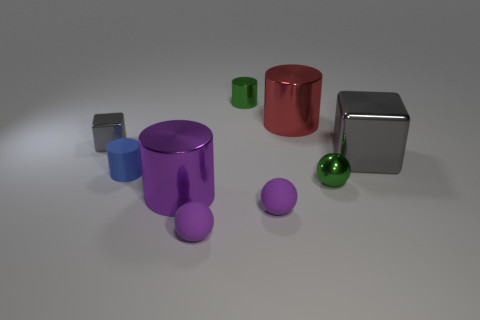What size is the other shiny block that is the same color as the big shiny block?
Your answer should be very brief. Small. What is the material of the other block that is the same color as the tiny cube?
Your response must be concise. Metal. How many red things are the same shape as the big gray object?
Offer a terse response. 0. Is the material of the tiny object behind the tiny gray shiny object the same as the gray cube to the left of the green metallic ball?
Make the answer very short. Yes. What is the size of the metallic cube that is to the right of the metal cylinder in front of the matte cylinder?
Make the answer very short. Large. Is there any other thing that has the same size as the green shiny ball?
Your response must be concise. Yes. There is a red object that is the same shape as the blue rubber thing; what material is it?
Offer a terse response. Metal. There is a shiny object that is to the left of the large purple metal object; is its shape the same as the tiny rubber thing to the left of the large purple shiny cylinder?
Offer a terse response. No. Are there more metal balls than green things?
Your response must be concise. No. What is the size of the red metal object?
Give a very brief answer. Large. 